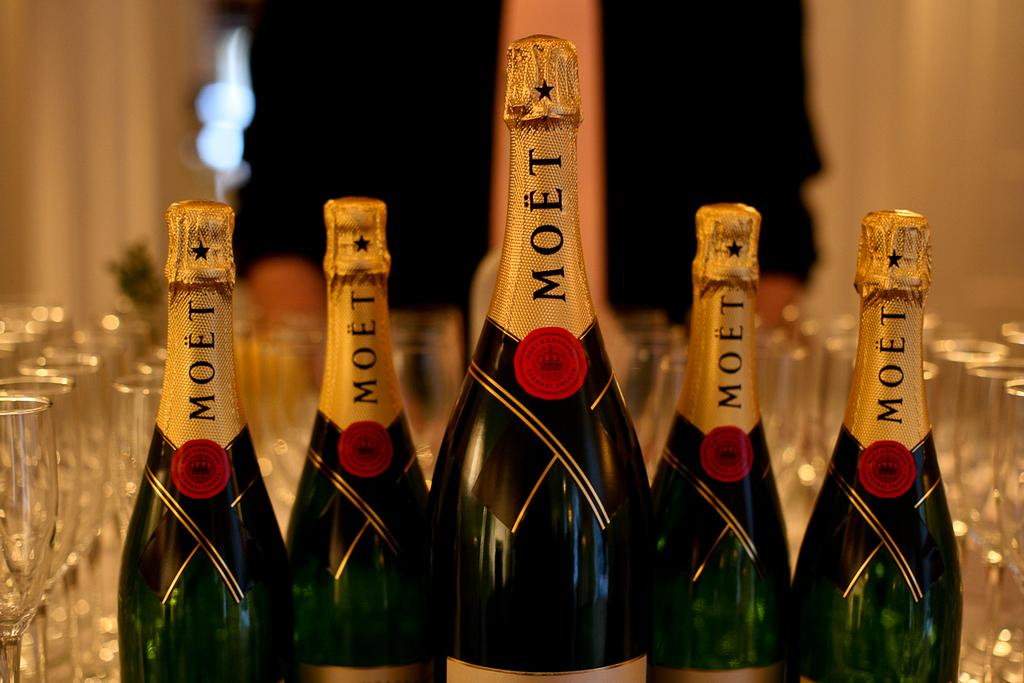<image>
Present a compact description of the photo's key features. Bottles of wine sit in a table with each other and MOET is written on it 